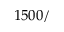Convert formula to latex. <formula><loc_0><loc_0><loc_500><loc_500>1 5 0 0 /</formula> 